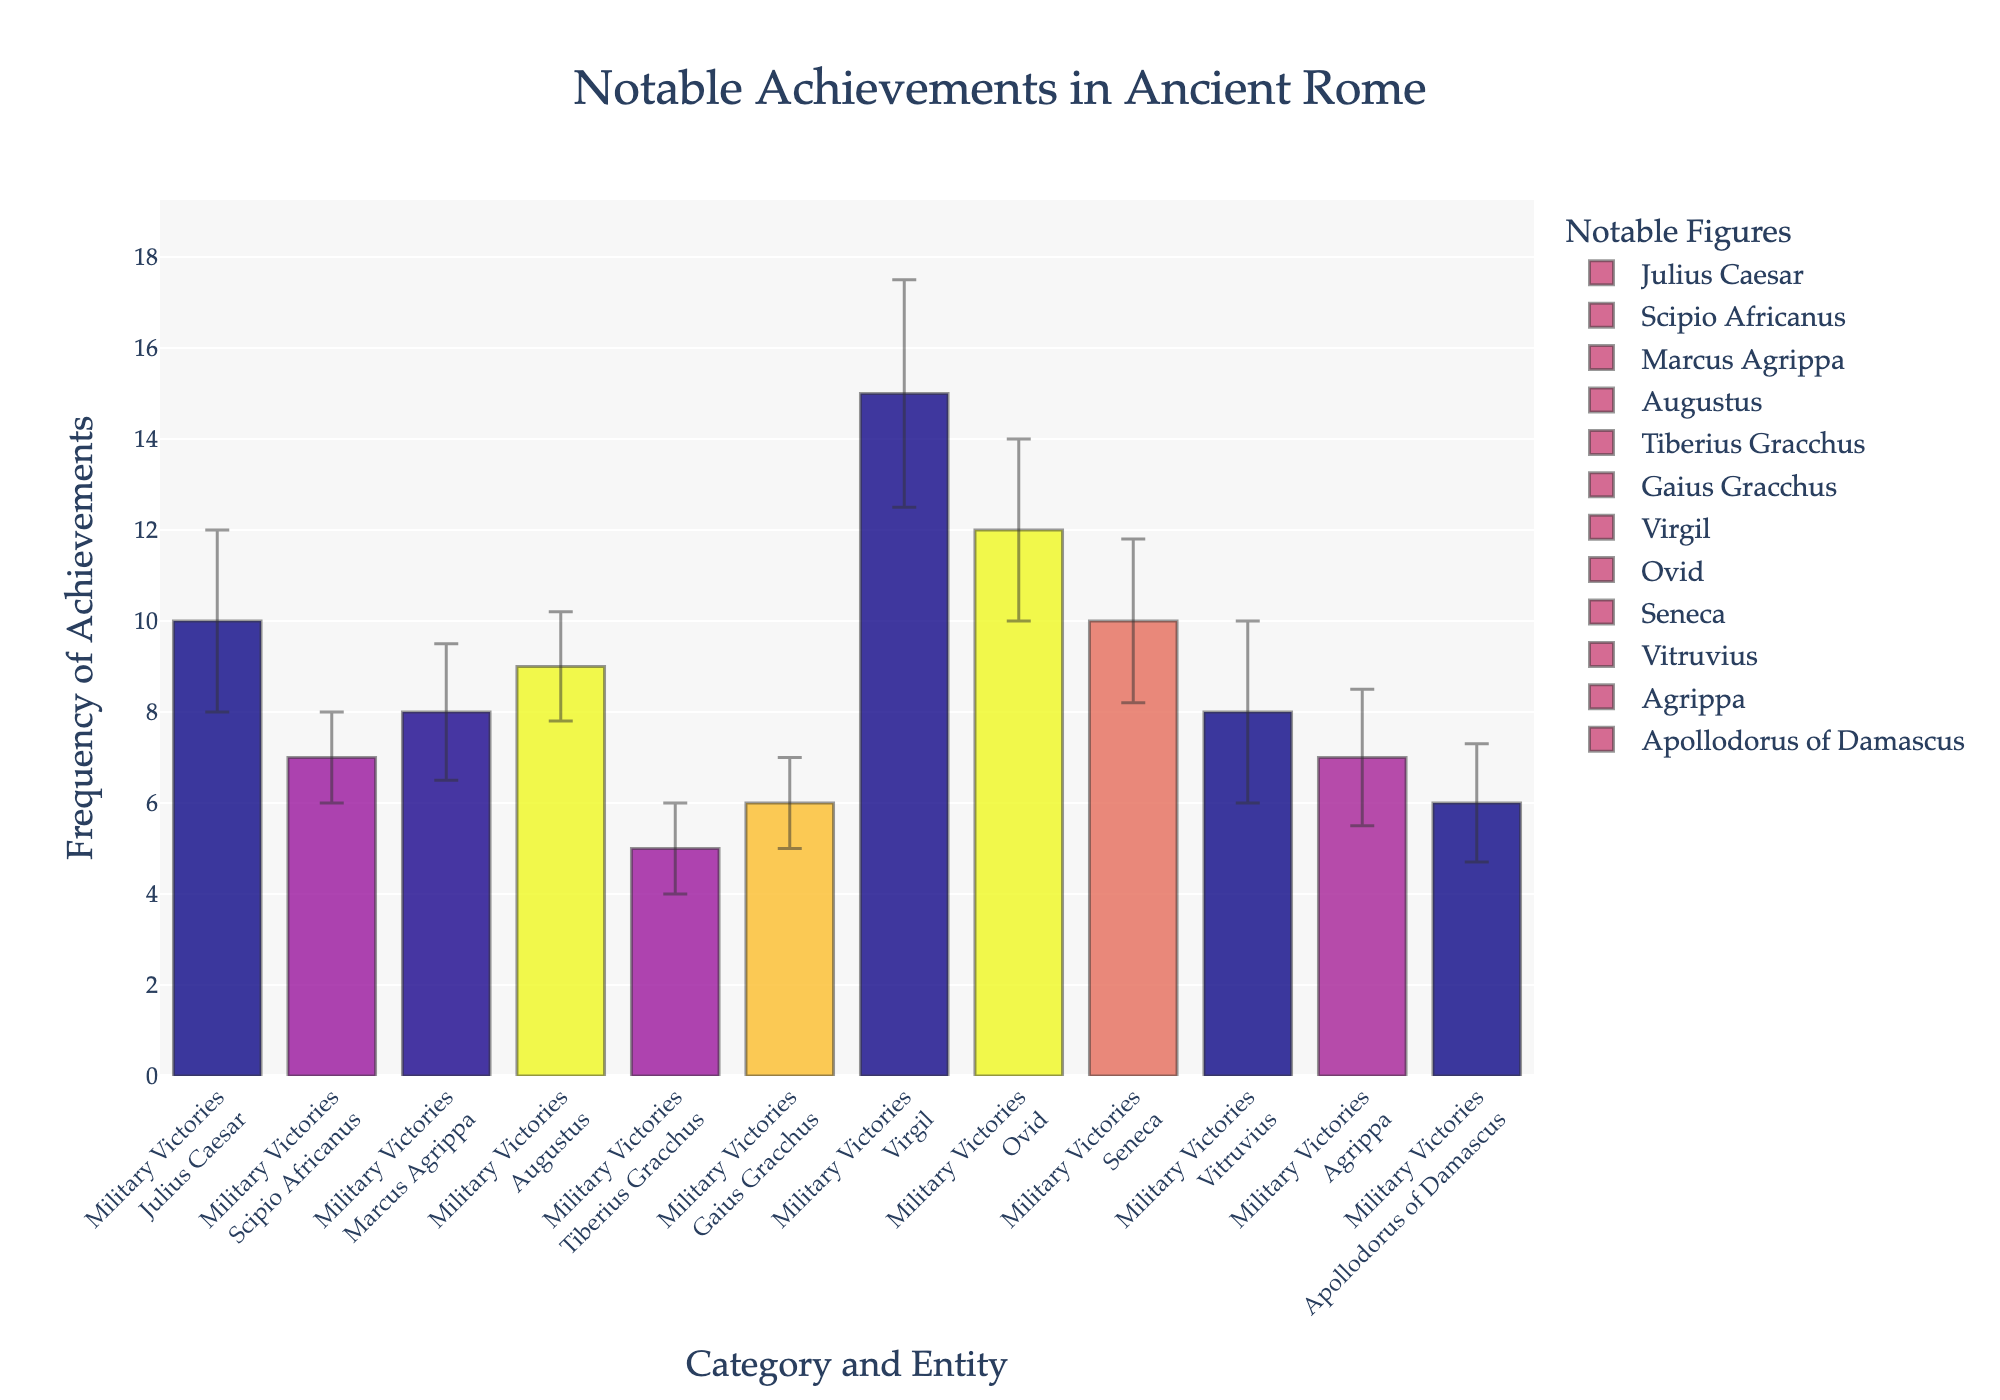what is the name of the highest category on the x-axis? The x-axis shows the categories, which are "Military Victories," "Political Reforms," "Literary Works," and "Architectural Contributions." The highest category is "Literary Works," referring to the greatest frequency of notable achievements.
Answer: Literary Works Which entity has the highest frequency of achievements in the "Military Victories" category? The "Military Victories" category shows frequency bars for Julius Caesar, Scipio Africanus, and Marcus Agrippa. Among them, Julius Caesar has the highest frequency.
Answer: Julius Caesar How does Ovid's frequency of literary works compare to Virgil's? By inspecting the bars for Ovid and Virgil in the "Literary Works" category, Ovid has a frequency of 12, whereas Virgil has a frequency of 15. Virgil has a higher frequency than Ovid.
Answer: Virgil has a higher frequency Which entity has the smallest frequency in the "Architectural Contributions" category? In "Architectural Contributions," the entities are Vitruvius, Agrippa, and Apollodorus of Damascus. Apollodorus of Damascus has the smallest frequency of achievements.
Answer: Apollodorus of Damascus Calculate the average frequency of political reforms between Augustus, Tiberius Gracchus, and Gaius Gracchus. To calculate the average, sum the frequencies: Augustus (9) + Tiberius Gracchus (5) + Gaius Gracchus (6) = 20. The average is 20 divided by 3, which equals about 6.67.
Answer: 6.67 What is the total frequency of military victories across all noted figures? Summing the frequencies of Julius Caesar (10), Scipio Africanus (7), and Marcus Agrippa (8), the total is 10 + 7 + 8 = 25.
Answer: 25 How much greater is the highest frequency in the chart compared to the lowest frequency? The highest frequency is Virgil's literary works (15), and the lowest is Tiberius Gracchus' political reforms (5). The difference is 15 - 5 = 10.
Answer: 10 Which category has the most consistent achievements considering the error bars? By examining the error bars, "Political Reforms" have relatively smaller and more consistent error bars compared to the other categories.
Answer: Political Reforms If you combined the frequencies of both Gracchus brothers in political reforms, how would it compare to Augustus' frequency in the same category? Tiberius Gracchus (5) + Gaius Gracchus (6) = 11. This is compared to Augustus' frequency of 9. The combined frequency of the Gracchus brothers is higher than Augustus'.
Answer: Higher than Augustus Is the sum of entity frequencies in "Architectural Contributions" category greater than that in "Military Victories" category? Sum the frequencies in "Architectural Contributions" (Vitruvius 8, Agrippa 7, Apollodorus 6) to get 8 + 7 + 6 = 21. For "Military Victories" (Julius Caesar 10, Scipio Africanus 7, Marcus Agrippa 8), the sum is 10 + 7 + 8 = 25. The sum for "Military Victories" is greater.
Answer: No 